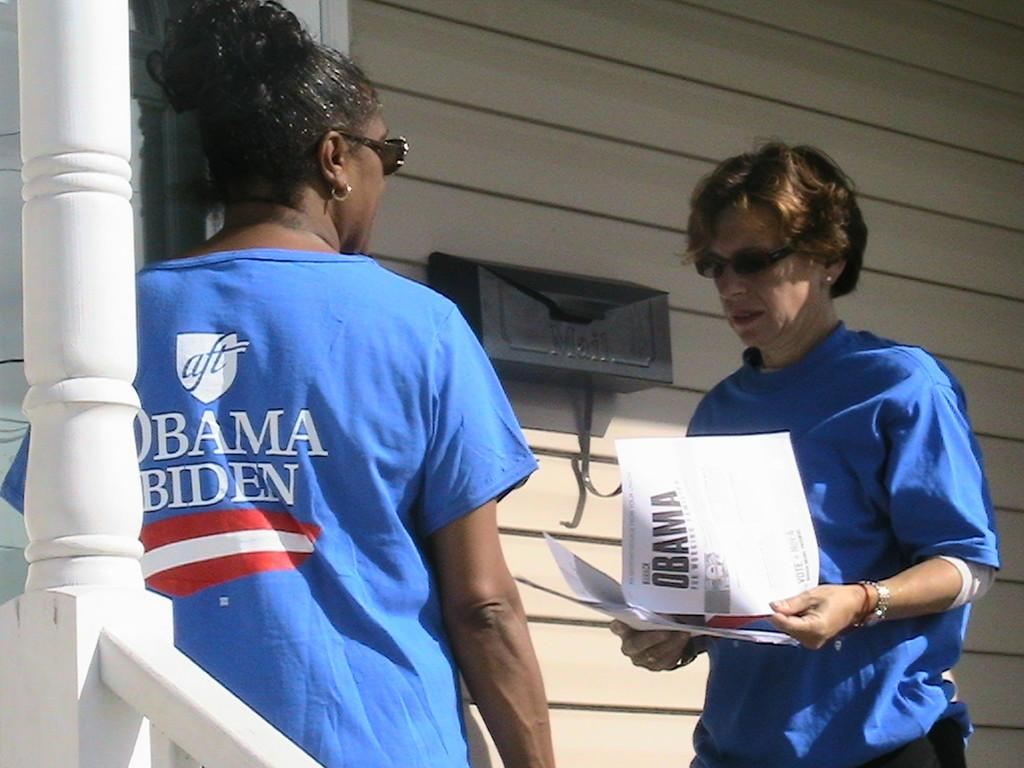How many people are present in the image? There are two people in the image. What is one of the people holding? One person is holding papers. Can you describe anything in the background of the image? There is an object on the wall in the background of the image. What type of pets can be seen playing with the pocket in the image? There are no pets or pockets present in the image. How many geese are visible in the image? There are no geese present in the image. 